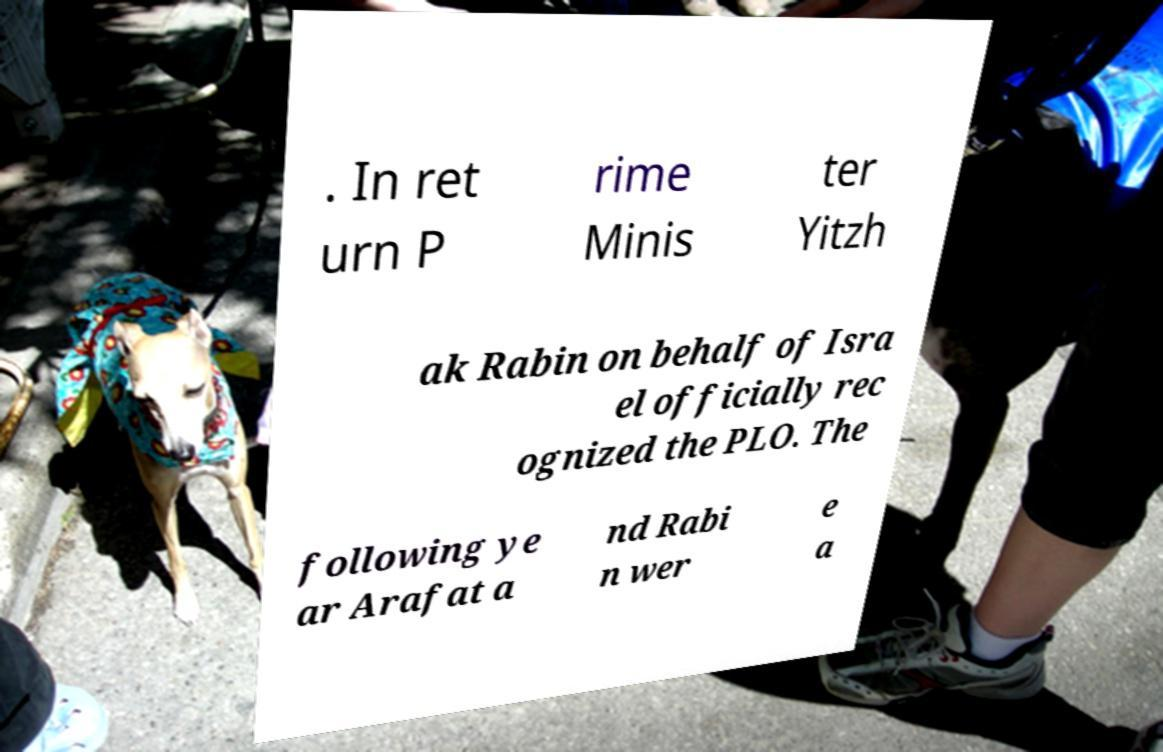For documentation purposes, I need the text within this image transcribed. Could you provide that? . In ret urn P rime Minis ter Yitzh ak Rabin on behalf of Isra el officially rec ognized the PLO. The following ye ar Arafat a nd Rabi n wer e a 